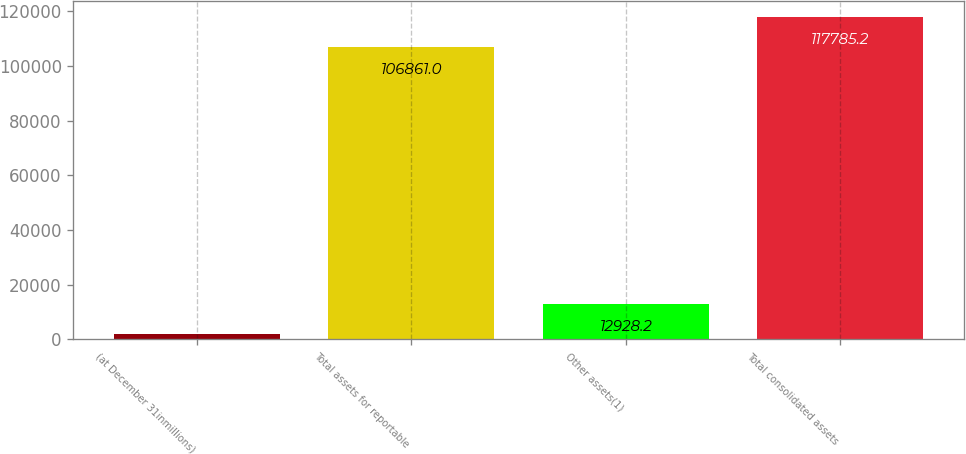Convert chart. <chart><loc_0><loc_0><loc_500><loc_500><bar_chart><fcel>(at December 31inmillions)<fcel>Total assets for reportable<fcel>Other assets(1)<fcel>Total consolidated assets<nl><fcel>2004<fcel>106861<fcel>12928.2<fcel>117785<nl></chart> 